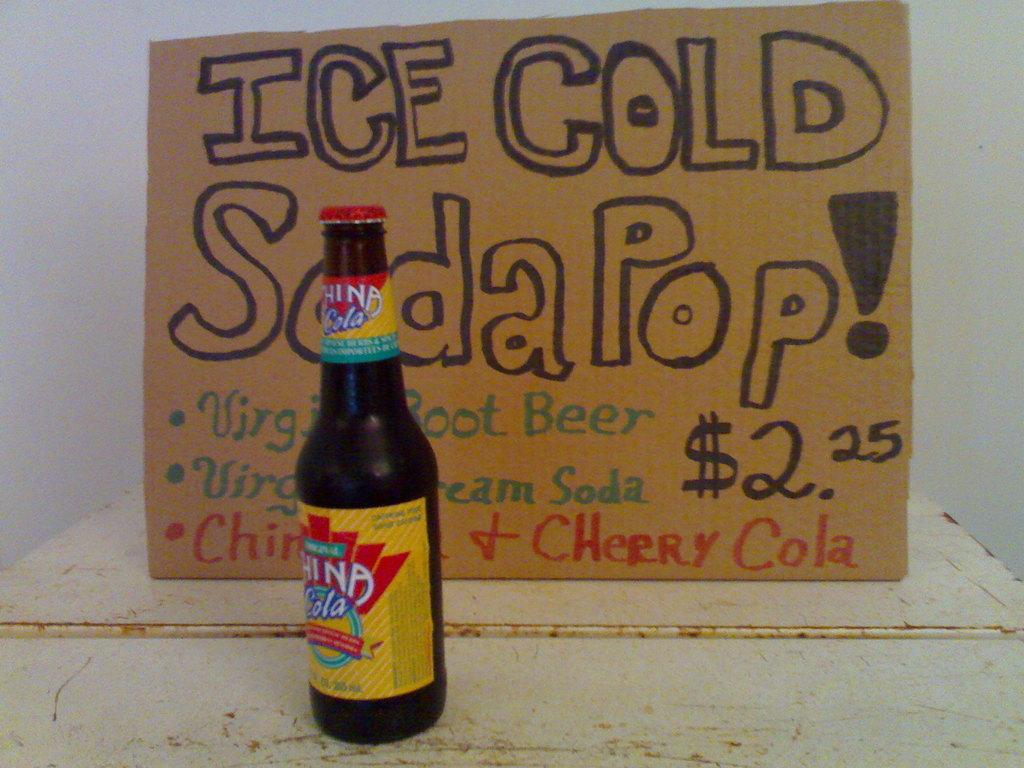<image>
Summarize the visual content of the image. A bottle sitting in front of a sign that reads Ice Cold Soda Pop. 